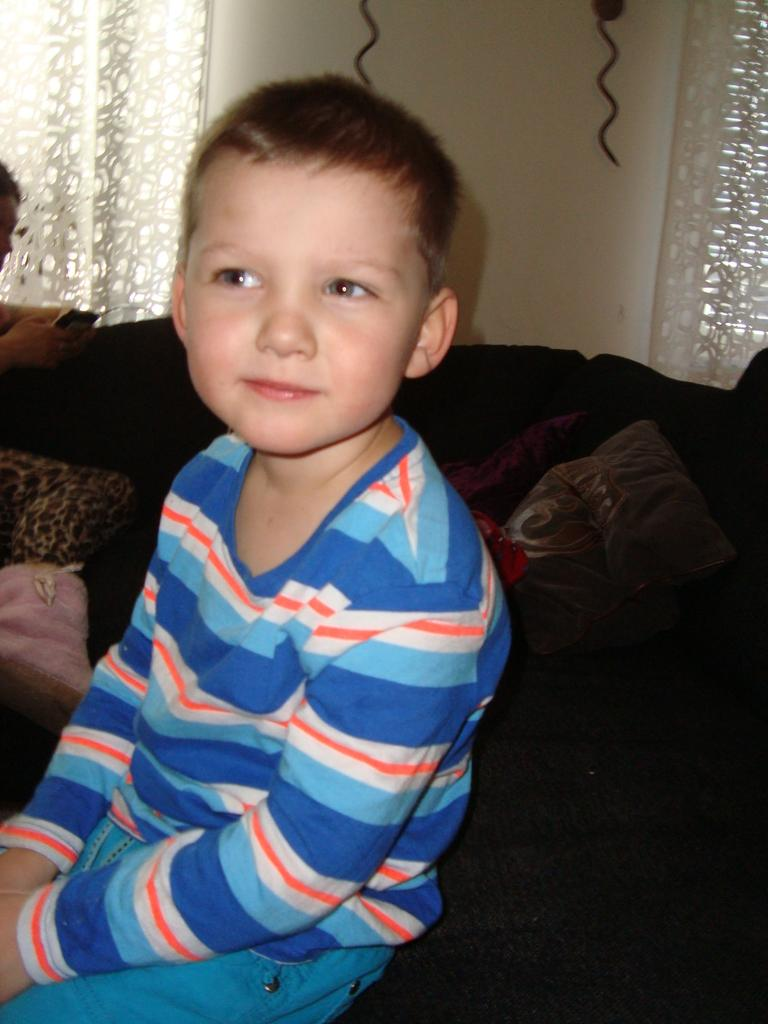Who is present in the image? There is a boy in the image. Where is the boy located? The boy is sitting in a room. What is the boy wearing? The boy is wearing a blue dress. What can be seen behind the boy? There are cushions behind the boy. What type of window treatment is present in the room? There are white curtains at the back of the room. What type of wood is used to make the selection of chairs in the image? There are no chairs present in the image, so it is not possible to determine the type of wood used. 